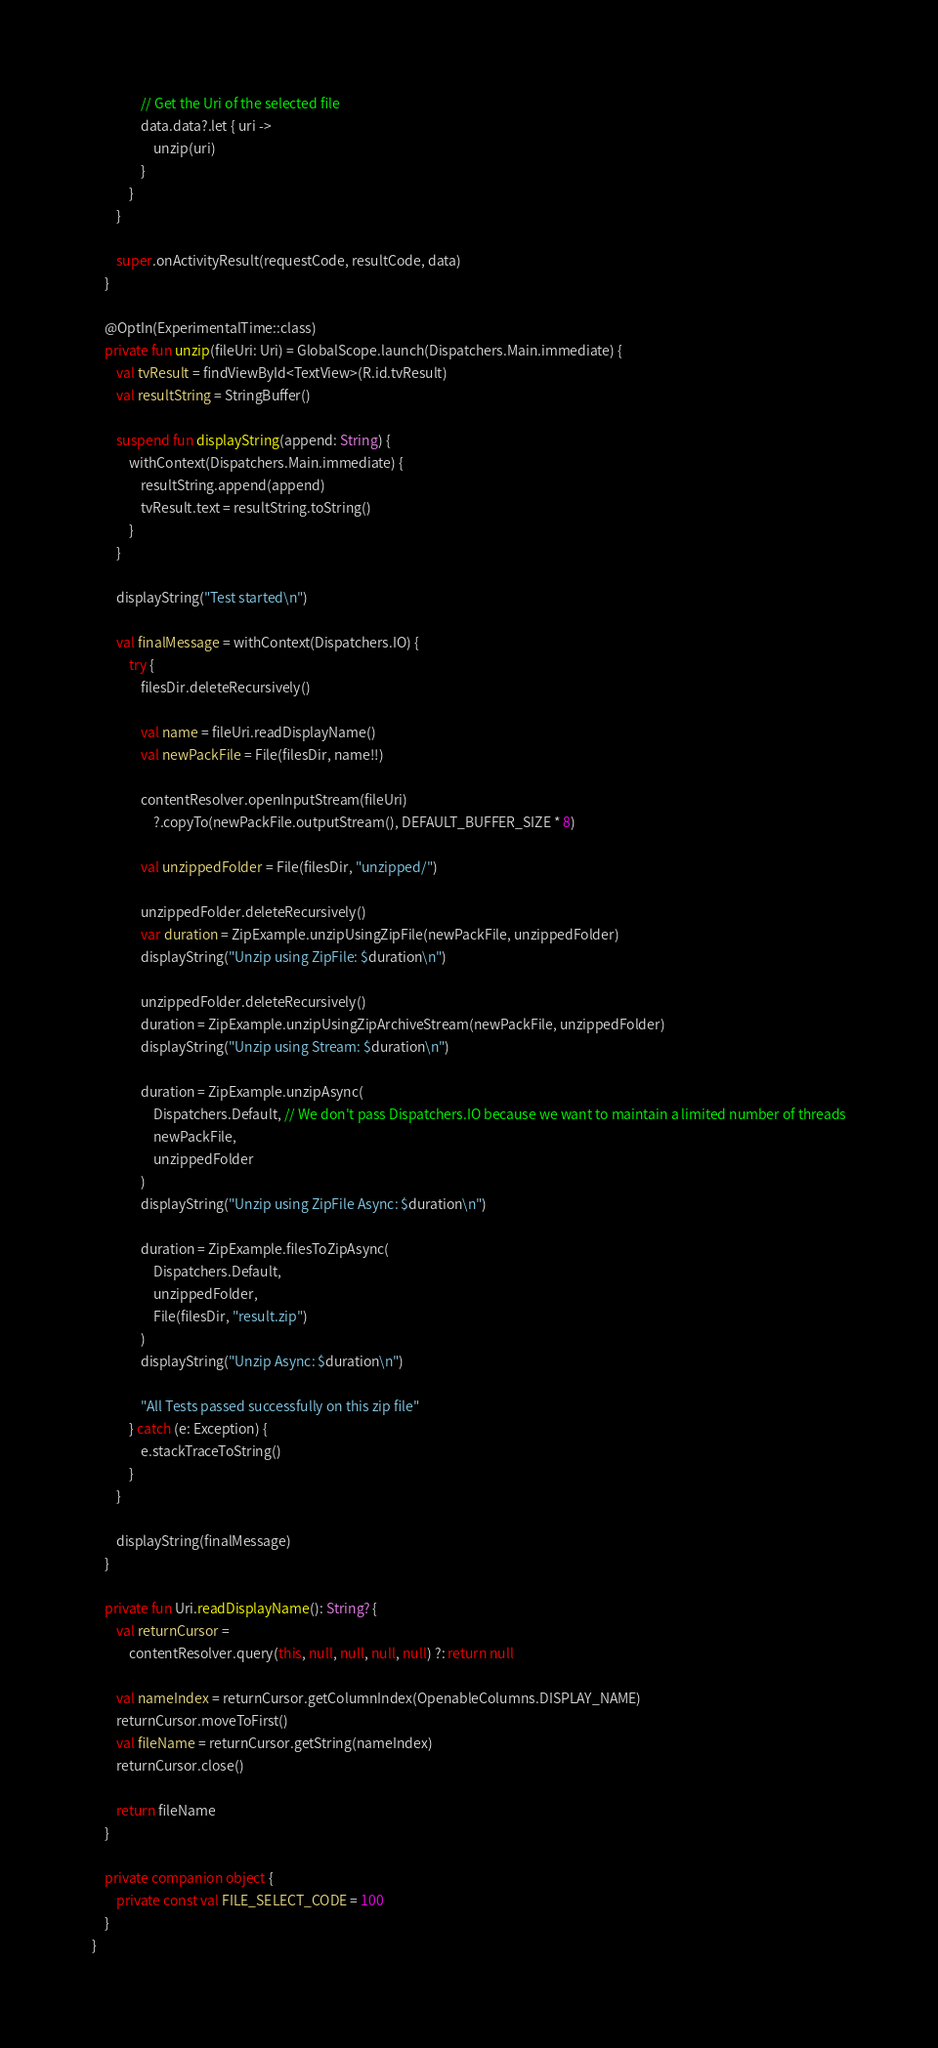Convert code to text. <code><loc_0><loc_0><loc_500><loc_500><_Kotlin_>                // Get the Uri of the selected file
                data.data?.let { uri ->
                    unzip(uri)
                }
            }
        }

        super.onActivityResult(requestCode, resultCode, data)
    }

    @OptIn(ExperimentalTime::class)
    private fun unzip(fileUri: Uri) = GlobalScope.launch(Dispatchers.Main.immediate) {
        val tvResult = findViewById<TextView>(R.id.tvResult)
        val resultString = StringBuffer()

        suspend fun displayString(append: String) {
            withContext(Dispatchers.Main.immediate) {
                resultString.append(append)
                tvResult.text = resultString.toString()
            }
        }

        displayString("Test started\n")

        val finalMessage = withContext(Dispatchers.IO) {
            try {
                filesDir.deleteRecursively()

                val name = fileUri.readDisplayName()
                val newPackFile = File(filesDir, name!!)

                contentResolver.openInputStream(fileUri)
                    ?.copyTo(newPackFile.outputStream(), DEFAULT_BUFFER_SIZE * 8)

                val unzippedFolder = File(filesDir, "unzipped/")

                unzippedFolder.deleteRecursively()
                var duration = ZipExample.unzipUsingZipFile(newPackFile, unzippedFolder)
                displayString("Unzip using ZipFile: $duration\n")

                unzippedFolder.deleteRecursively()
                duration = ZipExample.unzipUsingZipArchiveStream(newPackFile, unzippedFolder)
                displayString("Unzip using Stream: $duration\n")

                duration = ZipExample.unzipAsync(
                    Dispatchers.Default, // We don't pass Dispatchers.IO because we want to maintain a limited number of threads
                    newPackFile,
                    unzippedFolder
                )
                displayString("Unzip using ZipFile Async: $duration\n")

                duration = ZipExample.filesToZipAsync(
                    Dispatchers.Default,
                    unzippedFolder,
                    File(filesDir, "result.zip")
                )
                displayString("Unzip Async: $duration\n")

                "All Tests passed successfully on this zip file"
            } catch (e: Exception) {
                e.stackTraceToString()
            }
        }

        displayString(finalMessage)
    }

    private fun Uri.readDisplayName(): String? {
        val returnCursor =
            contentResolver.query(this, null, null, null, null) ?: return null

        val nameIndex = returnCursor.getColumnIndex(OpenableColumns.DISPLAY_NAME)
        returnCursor.moveToFirst()
        val fileName = returnCursor.getString(nameIndex)
        returnCursor.close()

        return fileName
    }

    private companion object {
        private const val FILE_SELECT_CODE = 100
    }
}</code> 